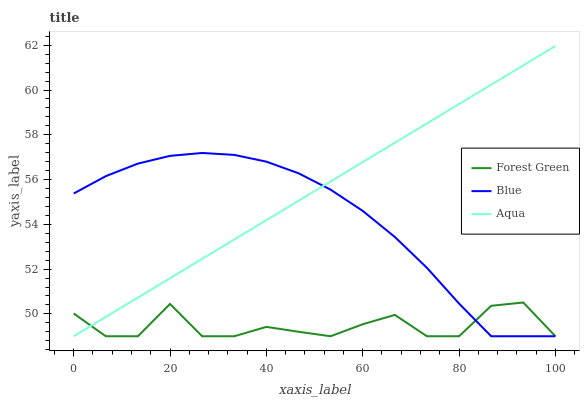Does Forest Green have the minimum area under the curve?
Answer yes or no. Yes. Does Aqua have the maximum area under the curve?
Answer yes or no. Yes. Does Aqua have the minimum area under the curve?
Answer yes or no. No. Does Forest Green have the maximum area under the curve?
Answer yes or no. No. Is Aqua the smoothest?
Answer yes or no. Yes. Is Forest Green the roughest?
Answer yes or no. Yes. Is Forest Green the smoothest?
Answer yes or no. No. Is Aqua the roughest?
Answer yes or no. No. Does Blue have the lowest value?
Answer yes or no. Yes. Does Aqua have the highest value?
Answer yes or no. Yes. Does Forest Green have the highest value?
Answer yes or no. No. Does Forest Green intersect Aqua?
Answer yes or no. Yes. Is Forest Green less than Aqua?
Answer yes or no. No. Is Forest Green greater than Aqua?
Answer yes or no. No. 